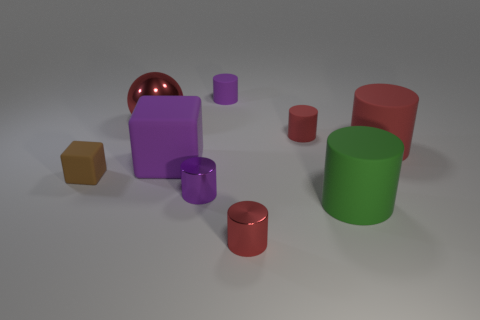Subtract all blue blocks. How many red cylinders are left? 3 Subtract 3 cylinders. How many cylinders are left? 3 Subtract all green cylinders. How many cylinders are left? 5 Subtract all small red cylinders. How many cylinders are left? 4 Subtract all yellow cylinders. Subtract all red balls. How many cylinders are left? 6 Add 1 large matte cubes. How many objects exist? 10 Subtract all cubes. How many objects are left? 7 Subtract all rubber cubes. Subtract all large cyan rubber cylinders. How many objects are left? 7 Add 4 small red metal objects. How many small red metal objects are left? 5 Add 9 green matte cylinders. How many green matte cylinders exist? 10 